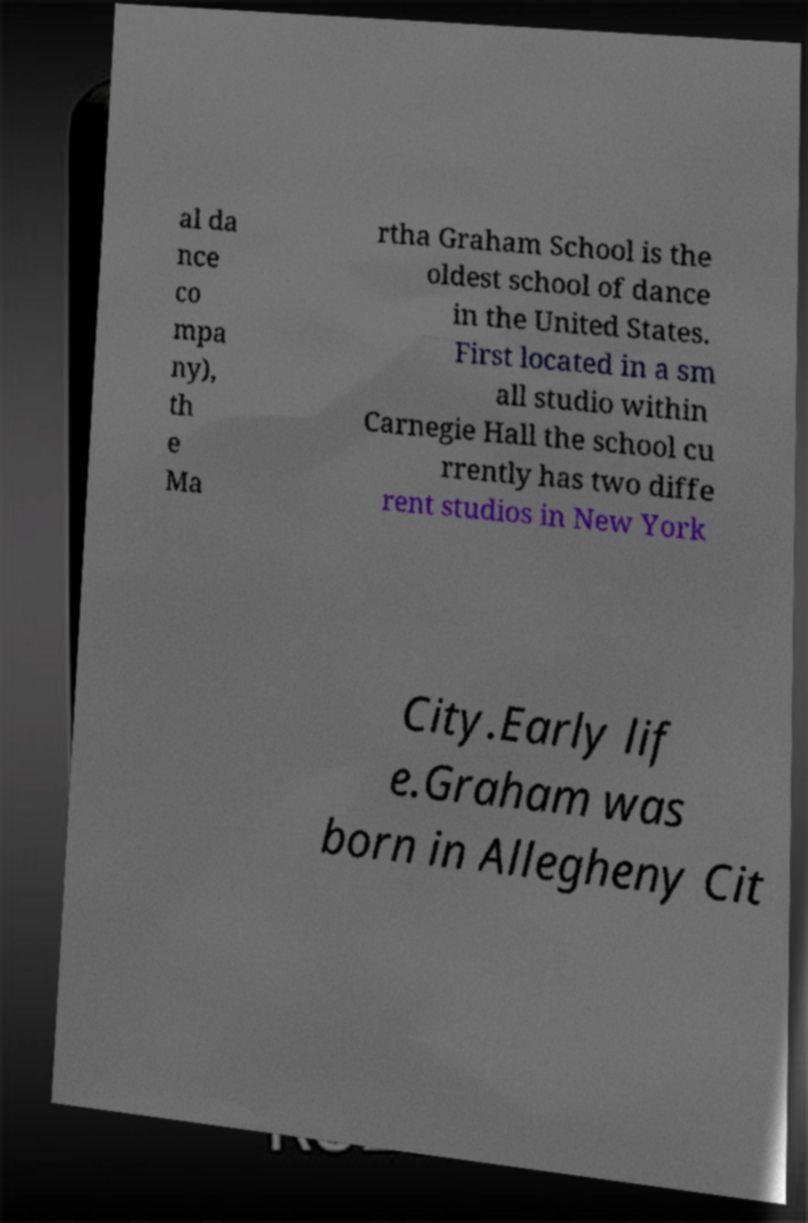Could you extract and type out the text from this image? al da nce co mpa ny), th e Ma rtha Graham School is the oldest school of dance in the United States. First located in a sm all studio within Carnegie Hall the school cu rrently has two diffe rent studios in New York City.Early lif e.Graham was born in Allegheny Cit 